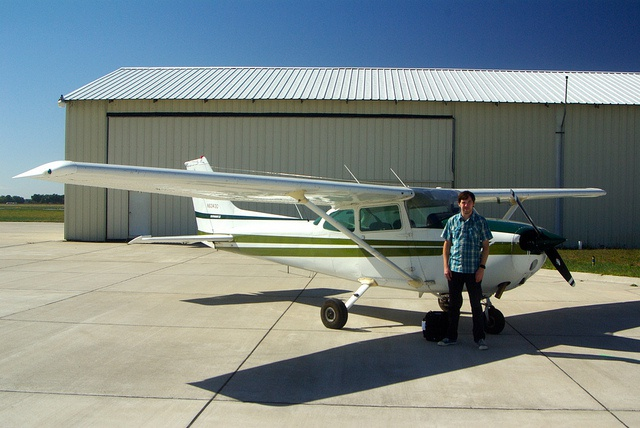Describe the objects in this image and their specific colors. I can see airplane in gray, darkgray, black, and ivory tones, people in gray, black, maroon, and blue tones, and suitcase in gray and black tones in this image. 